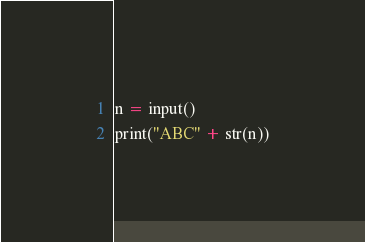Convert code to text. <code><loc_0><loc_0><loc_500><loc_500><_Python_>n = input()
print("ABC" + str(n))</code> 